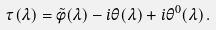<formula> <loc_0><loc_0><loc_500><loc_500>\tau ( \lambda ) = \tilde { \phi } ( \lambda ) - i \theta ( \lambda ) + i \theta ^ { 0 } ( \lambda ) \, .</formula> 